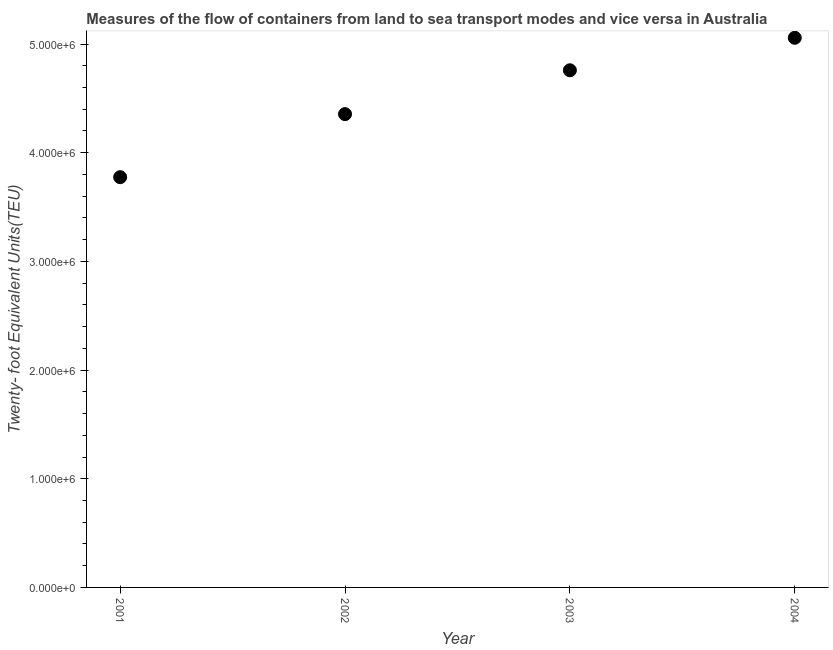What is the container port traffic in 2002?
Your answer should be compact. 4.36e+06. Across all years, what is the maximum container port traffic?
Provide a short and direct response. 5.06e+06. Across all years, what is the minimum container port traffic?
Provide a short and direct response. 3.77e+06. In which year was the container port traffic maximum?
Make the answer very short. 2004. What is the sum of the container port traffic?
Offer a very short reply. 1.79e+07. What is the difference between the container port traffic in 2001 and 2003?
Provide a succinct answer. -9.84e+05. What is the average container port traffic per year?
Give a very brief answer. 4.49e+06. What is the median container port traffic?
Your response must be concise. 4.56e+06. What is the ratio of the container port traffic in 2002 to that in 2003?
Offer a very short reply. 0.92. Is the difference between the container port traffic in 2001 and 2003 greater than the difference between any two years?
Provide a short and direct response. No. What is the difference between the highest and the second highest container port traffic?
Make the answer very short. 2.99e+05. Is the sum of the container port traffic in 2003 and 2004 greater than the maximum container port traffic across all years?
Provide a succinct answer. Yes. What is the difference between the highest and the lowest container port traffic?
Provide a succinct answer. 1.28e+06. What is the difference between two consecutive major ticks on the Y-axis?
Your answer should be very brief. 1.00e+06. Does the graph contain any zero values?
Give a very brief answer. No. What is the title of the graph?
Give a very brief answer. Measures of the flow of containers from land to sea transport modes and vice versa in Australia. What is the label or title of the Y-axis?
Provide a short and direct response. Twenty- foot Equivalent Units(TEU). What is the Twenty- foot Equivalent Units(TEU) in 2001?
Ensure brevity in your answer.  3.77e+06. What is the Twenty- foot Equivalent Units(TEU) in 2002?
Keep it short and to the point. 4.36e+06. What is the Twenty- foot Equivalent Units(TEU) in 2003?
Provide a succinct answer. 4.76e+06. What is the Twenty- foot Equivalent Units(TEU) in 2004?
Offer a terse response. 5.06e+06. What is the difference between the Twenty- foot Equivalent Units(TEU) in 2001 and 2002?
Ensure brevity in your answer.  -5.80e+05. What is the difference between the Twenty- foot Equivalent Units(TEU) in 2001 and 2003?
Ensure brevity in your answer.  -9.84e+05. What is the difference between the Twenty- foot Equivalent Units(TEU) in 2001 and 2004?
Provide a succinct answer. -1.28e+06. What is the difference between the Twenty- foot Equivalent Units(TEU) in 2002 and 2003?
Provide a succinct answer. -4.03e+05. What is the difference between the Twenty- foot Equivalent Units(TEU) in 2002 and 2004?
Provide a short and direct response. -7.02e+05. What is the difference between the Twenty- foot Equivalent Units(TEU) in 2003 and 2004?
Keep it short and to the point. -2.99e+05. What is the ratio of the Twenty- foot Equivalent Units(TEU) in 2001 to that in 2002?
Offer a very short reply. 0.87. What is the ratio of the Twenty- foot Equivalent Units(TEU) in 2001 to that in 2003?
Provide a short and direct response. 0.79. What is the ratio of the Twenty- foot Equivalent Units(TEU) in 2001 to that in 2004?
Keep it short and to the point. 0.75. What is the ratio of the Twenty- foot Equivalent Units(TEU) in 2002 to that in 2003?
Offer a terse response. 0.92. What is the ratio of the Twenty- foot Equivalent Units(TEU) in 2002 to that in 2004?
Make the answer very short. 0.86. What is the ratio of the Twenty- foot Equivalent Units(TEU) in 2003 to that in 2004?
Your answer should be very brief. 0.94. 